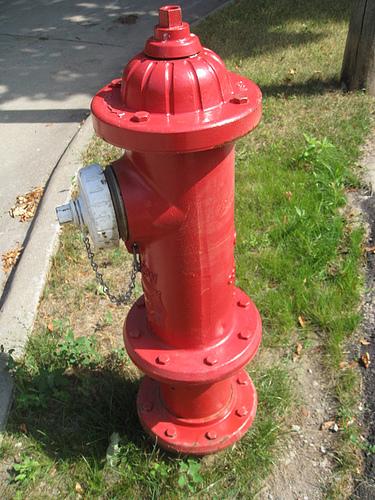Is the grass all the same length?
Be succinct. No. Is there a chain on the fire hydrant?
Keep it brief. Yes. Is this fire hydrant located next to a street?
Short answer required. Yes. 